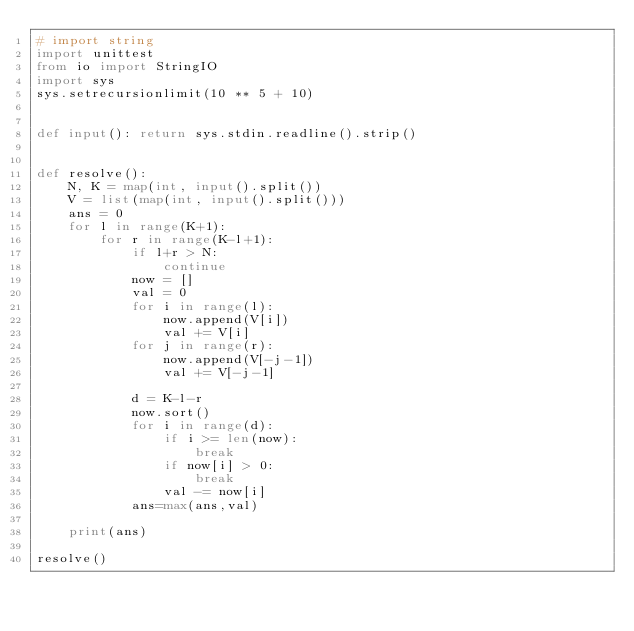Convert code to text. <code><loc_0><loc_0><loc_500><loc_500><_Python_># import string
import unittest
from io import StringIO
import sys
sys.setrecursionlimit(10 ** 5 + 10)


def input(): return sys.stdin.readline().strip()


def resolve():
    N, K = map(int, input().split())
    V = list(map(int, input().split()))
    ans = 0
    for l in range(K+1):
        for r in range(K-l+1):
            if l+r > N:
                continue
            now = []
            val = 0
            for i in range(l):
                now.append(V[i])
                val += V[i]
            for j in range(r):
                now.append(V[-j-1])
                val += V[-j-1]

            d = K-l-r
            now.sort()
            for i in range(d):
                if i >= len(now):
                    break
                if now[i] > 0:
                    break
                val -= now[i]
            ans=max(ans,val)

    print(ans)

resolve()</code> 